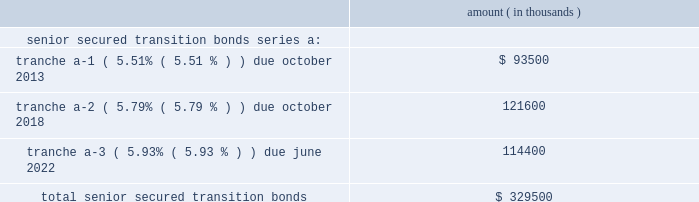Entergy corporation and subsidiaries notes to financial statements in november 2000 , entergy's non-utility nuclear business purchased the fitzpatrick and indian point 3 power plants in a seller-financed transaction .
Entergy issued notes to nypa with seven annual installments of approximately $ 108 million commencing one year from the date of the closing , and eight annual installments of $ 20 million commencing eight years from the date of the closing .
These notes do not have a stated interest rate , but have an implicit interest rate of 4.8% ( 4.8 % ) .
In accordance with the purchase agreement with nypa , the purchase of indian point 2 in 2001 resulted in entergy's non-utility nuclear business becoming liable to nypa for an additional $ 10 million per year for 10 years , beginning in september 2003 .
This liability was recorded upon the purchase of indian point 2 in september 2001 , and is included in the note payable to nypa balance above .
In july 2003 , a payment of $ 102 million was made prior to maturity on the note payable to nypa .
Under a provision in a letter of credit supporting these notes , if certain of the utility operating companies or system energy were to default on other indebtedness , entergy could be required to post collateral to support the letter of credit .
Covenants in the entergy corporation notes require it to maintain a consolidated debt ratio of 65% ( 65 % ) or less of its total capitalization .
If entergy's debt ratio exceeds this limit , or if entergy corporation or certain of the utility operating companies default on other indebtedness or are in bankruptcy or insolvency proceedings , an acceleration of the notes' maturity dates may occur .
Entergy gulf states louisiana , entergy louisiana , entergy mississippi , entergy texas , and system energy have received ferc long-term financing orders authorizing long-term securities issuances .
Entergy arkansas has received an apsc long-term financing order authorizing long-term securities issuances .
The long-term securities issuances of entergy new orleans are limited to amounts authorized by the city council , and the current authorization extends through august 2010 .
Capital funds agreement pursuant to an agreement with certain creditors , entergy corporation has agreed to supply system energy with sufficient capital to : maintain system energy's equity capital at a minimum of 35% ( 35 % ) of its total capitalization ( excluding short- term debt ) ; permit the continued commercial operation of grand gulf ; pay in full all system energy indebtedness for borrowed money when due ; and enable system energy to make payments on specific system energy debt , under supplements to the agreement assigning system energy's rights in the agreement as security for the specific debt .
Entergy texas securitization bonds - hurricane rita in april 2007 , the puct issued a financing order authorizing the issuance of securitization bonds to recover $ 353 million of entergy texas' hurricane rita reconstruction costs and up to $ 6 million of transaction costs , offset by $ 32 million of related deferred income tax benefits .
In june 2007 , entergy gulf states reconstruction funding i , llc , a company wholly-owned and consolidated by entergy texas , issued $ 329.5 million of senior secured transition bonds ( securitization bonds ) , as follows : amount ( in thousands ) .

In 2007 what was percent of the total senior secured transition bonds that was tranche a-2 due in october 2018? 
Computations: (121600 / 329500)
Answer: 0.36904. 